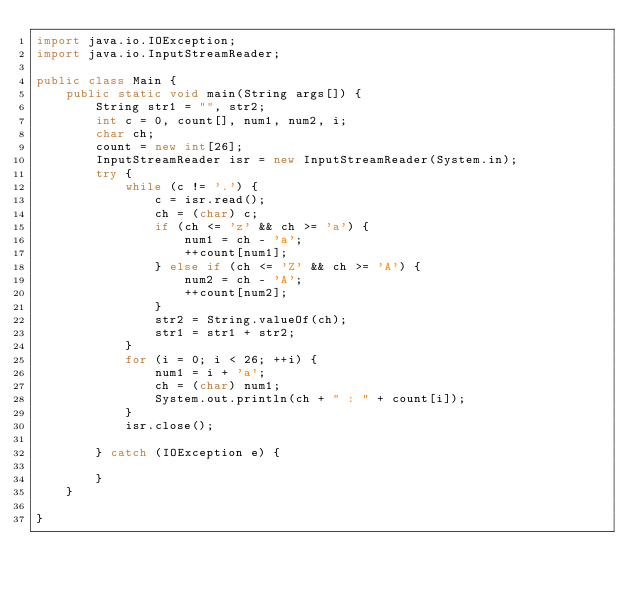<code> <loc_0><loc_0><loc_500><loc_500><_Java_>import java.io.IOException;
import java.io.InputStreamReader;

public class Main {
	public static void main(String args[]) {
		String str1 = "", str2;
		int c = 0, count[], num1, num2, i;
		char ch;
		count = new int[26];
		InputStreamReader isr = new InputStreamReader(System.in);
		try {
			while (c != '.') {
				c = isr.read();
				ch = (char) c;
				if (ch <= 'z' && ch >= 'a') {
					num1 = ch - 'a';
					++count[num1];
				} else if (ch <= 'Z' && ch >= 'A') {
					num2 = ch - 'A';
					++count[num2];
				}
				str2 = String.valueOf(ch);
				str1 = str1 + str2;
			}
			for (i = 0; i < 26; ++i) {
				num1 = i + 'a';
				ch = (char) num1;
				System.out.println(ch + " : " + count[i]);
			}
			isr.close();

		} catch (IOException e) {

		}
	}

}
</code> 